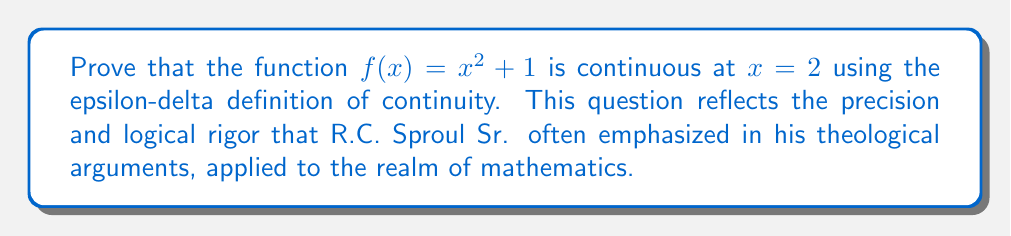Can you answer this question? To prove the continuity of $f(x) = x^2 + 1$ at $x = 2$ using the epsilon-delta definition, we need to show that for any $\epsilon > 0$, there exists a $\delta > 0$ such that:

$$|f(x) - f(2)| < \epsilon \text{ whenever } |x - 2| < \delta$$

Let's proceed step by step:

1) First, we calculate $f(2)$:
   $f(2) = 2^2 + 1 = 5$

2) Now, let's consider $|f(x) - f(2)|$:
   $$|f(x) - f(2)| = |(x^2 + 1) - 5| = |x^2 - 4|$$

3) We can factor this:
   $$|x^2 - 4| = |(x+2)(x-2)|$$

4) Now, let's consider $|x - 2| < \delta$. This implies $-\delta < x - 2 < \delta$, or $2 - \delta < x < 2 + \delta$.

5) If we choose $\delta \leq 1$, then $|x + 2| < 5$ whenever $|x - 2| < \delta$. This is because:
   $1 < x + 2 < 5$ when $-1 < x - 2 < 1$

6) Using this, we can say:
   $$|(x+2)(x-2)| < 5|x-2| \text{ when } |x-2| < \delta \leq 1$$

7) So, to ensure $|f(x) - f(2)| < \epsilon$, we need:
   $$5|x-2| < \epsilon$$

8) This will be true if we choose $\delta = \min(1, \frac{\epsilon}{5})$.

Therefore, for any $\epsilon > 0$, if we choose $\delta = \min(1, \frac{\epsilon}{5})$, we have:

$$|f(x) - f(2)| < \epsilon \text{ whenever } |x - 2| < \delta$$

This proves the continuity of $f(x) = x^2 + 1$ at $x = 2$.
Answer: The function $f(x) = x^2 + 1$ is continuous at $x = 2$. For any $\epsilon > 0$, choose $\delta = \min(1, \frac{\epsilon}{5})$. Then $|f(x) - f(2)| < \epsilon$ whenever $|x - 2| < \delta$, satisfying the epsilon-delta definition of continuity. 